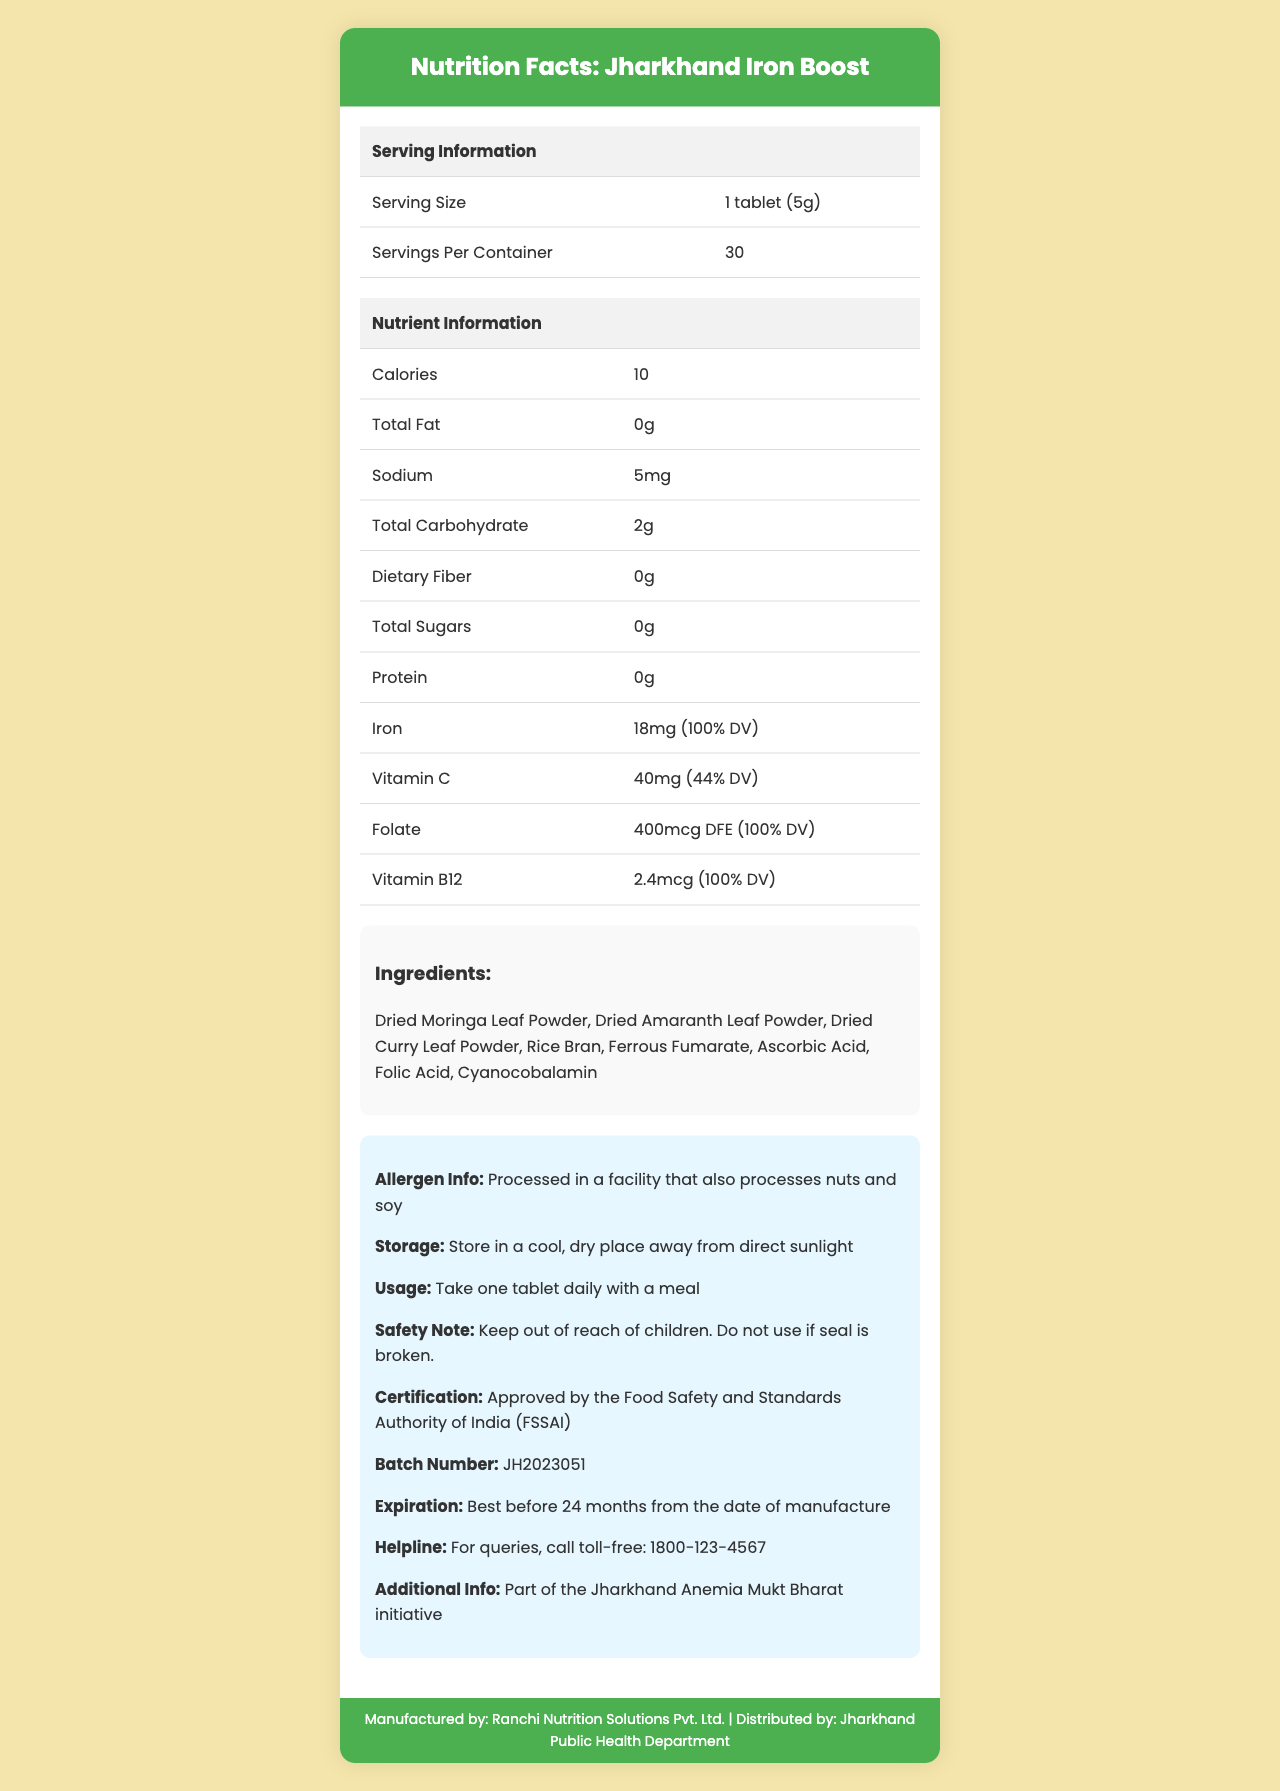what is the serving size? The serving size is clearly listed under the Serving Information section in the document.
Answer: 1 tablet (5g) how many calories are in one serving? The calories per serving are listed under the Nutrient Information section.
Answer: 10 which ingredient is used in the supplement? This is one of the ingredients listed in the Ingredients section.
Answer: Dried Moringa Leaf Powder who manufactures the product? The manufacturer information is provided in the footer of the document.
Answer: Ranchi Nutrition Solutions Pvt. Ltd. what is the expiration date of the product? This information is listed under the info section with storage and other instructions.
Answer: Best before 24 months from the date of manufacture what is the target audience for this supplement? The target audience is clearly mentioned under the Additional Info section.
Answer: Women of reproductive age and adolescent girls in rural Jharkhand how should the supplement be stored? A. In a moist environment B. In a cool, dry place away from direct sunlight C. In the refrigerator D. No specific instructions The storage instructions are specified in the Storage Instructions section.
Answer: B which nutrient has 100% daily value in this supplement? A. Vitamin C B. Dietary Fiber C. Iron D. Sodium The Iron content shows 18mg which is 100% of the daily value as indicated in the Nutrient Information section.
Answer: C does this supplement contain any potential allergens? The document mentions that it is processed in a facility that processes nuts and soy.
Answer: Yes is this product certified by any authority? The document mentions that it is approved by the Food Safety and Standards Authority of India (FSSAI).
Answer: Yes what is the main purpose of the 'Jharkhand Iron Boost' supplement? The main idea is evident from the documentation detailing high iron content, the target audience, and inclusion in the Jharkhand Anemia Mukt Bharat initiative.
Answer: The main purpose of the supplement is to prevent anemia in rural Jharkhand by providing an iron-rich supplement. what is the batch number of this product? The batch number is provided under the info section.
Answer: JH2023051 what additional vitamins are included in this supplement? These vitamins are listed under the Nutrient Information section.
Answer: Vitamin C, Folate, Vitamin B12 which organization distributes this supplement? The distributor is mentioned in the footer of the document.
Answer: Jharkhand Public Health Department can this supplement be used if the safety seal is broken? The Safety Note section advises against using the product if the seal is broken.
Answer: No how many tablets are there in one container? There are 30 servings per container, as listed under the Serving Information section.
Answer: 30 where is this supplement approved? The document confirms its approval by FSSAI under the certification section.
Answer: Food Safety and Standards Authority of India (FSSAI) what should you do if you have questions about the supplement? The helpline information is provided under the info section.
Answer: Call the toll-free helpline: 1800-123-4567 what is the daily value percentage of Vitamin C in the supplement? The Vitamin C daily value percentage is provided in the Nutrient Information section.
Answer: 44% what type of iron is included in this supplement? This is listed as one of the ingredients in the Ingredients section.
Answer: Ferrous Fumarate is it safe to give this supplement to children? The Safety Note advises keeping the supplement out of reach of children.
Answer: Keep out of reach of children 